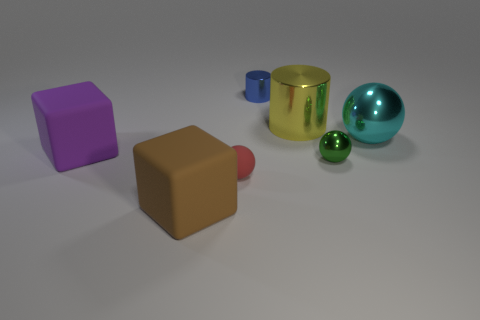There is a cylinder in front of the tiny object that is behind the yellow thing; what color is it?
Your answer should be very brief. Yellow. Are there any other things that have the same shape as the small red thing?
Make the answer very short. Yes. Is the number of small green spheres that are in front of the small green ball the same as the number of red rubber balls that are behind the large cyan thing?
Your answer should be compact. Yes. What number of blocks are either large objects or big yellow things?
Provide a short and direct response. 2. How many other things are made of the same material as the big cylinder?
Your answer should be very brief. 3. There is a blue object that is behind the large brown block; what is its shape?
Offer a terse response. Cylinder. There is a big cube in front of the matte cube that is behind the tiny green ball; what is its material?
Make the answer very short. Rubber. Is the number of big brown things on the right side of the tiny cylinder greater than the number of large rubber things?
Your answer should be compact. No. What number of other objects are the same color as the small rubber thing?
Give a very brief answer. 0. What is the shape of the red object that is the same size as the green object?
Give a very brief answer. Sphere. 